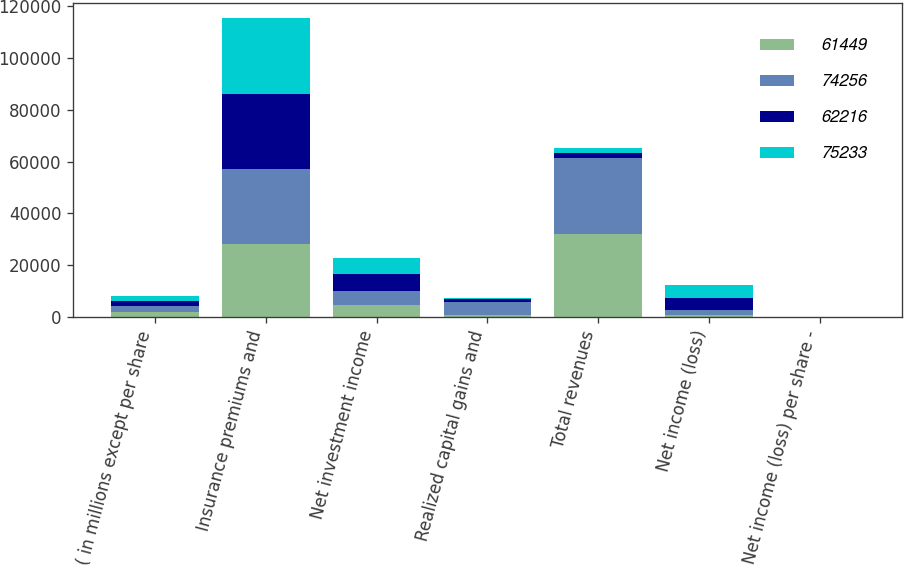Convert chart to OTSL. <chart><loc_0><loc_0><loc_500><loc_500><stacked_bar_chart><ecel><fcel>( in millions except per share<fcel>Insurance premiums and<fcel>Net investment income<fcel>Realized capital gains and<fcel>Total revenues<fcel>Net income (loss)<fcel>Net income (loss) per share -<nl><fcel>61449<fcel>2009<fcel>28152<fcel>4444<fcel>583<fcel>32013<fcel>854<fcel>1.58<nl><fcel>74256<fcel>2008<fcel>28862<fcel>5622<fcel>5090<fcel>29394<fcel>1679<fcel>3.06<nl><fcel>62216<fcel>2007<fcel>29099<fcel>6435<fcel>1235<fcel>2007.5<fcel>4636<fcel>7.76<nl><fcel>75233<fcel>2006<fcel>29333<fcel>6177<fcel>286<fcel>2007.5<fcel>4993<fcel>7.83<nl></chart> 